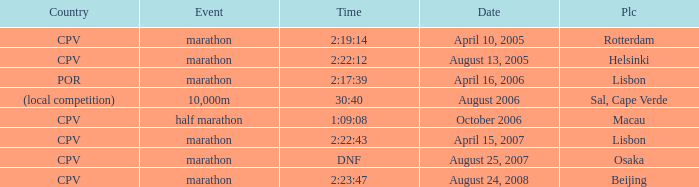What is the Date of the Event with a Time of 2:23:47? August 24, 2008. 